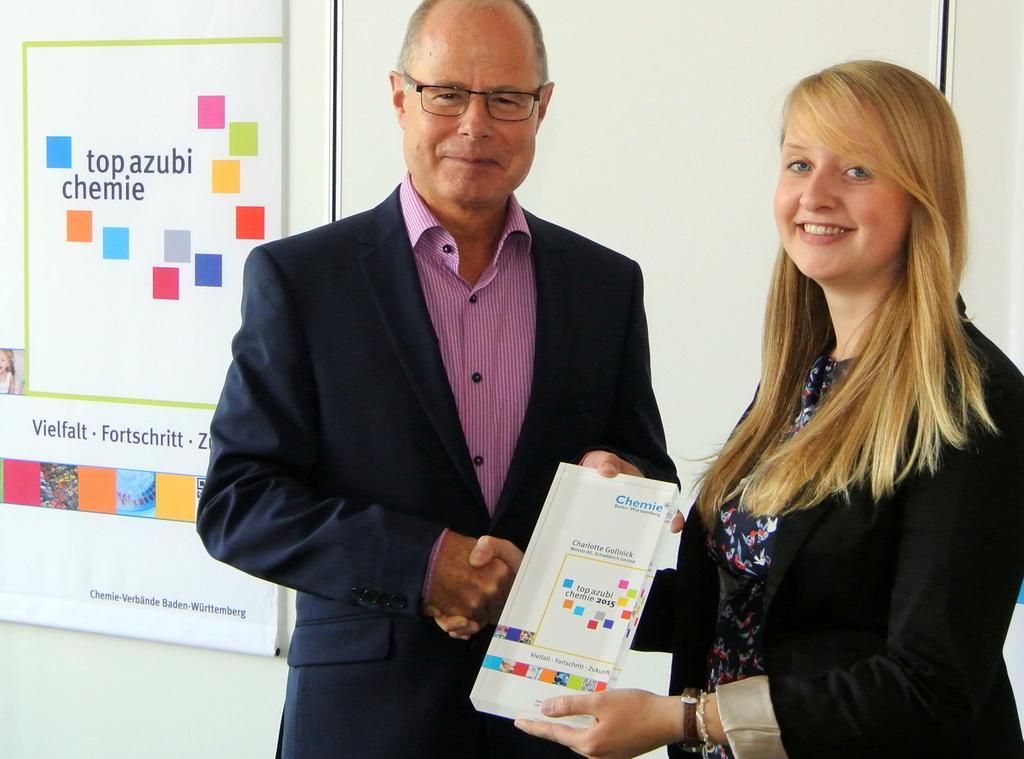Could you give a brief overview of what you see in this image? These two people are holding board, smiling and shaking their hands. Board is on the wall. On these boards there are colorful cubes and pictures. Something written on these boards. 